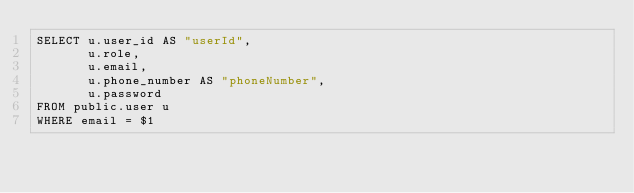Convert code to text. <code><loc_0><loc_0><loc_500><loc_500><_SQL_>SELECT u.user_id AS "userId",
       u.role,
       u.email,
       u.phone_number AS "phoneNumber",
       u.password
FROM public.user u
WHERE email = $1
</code> 